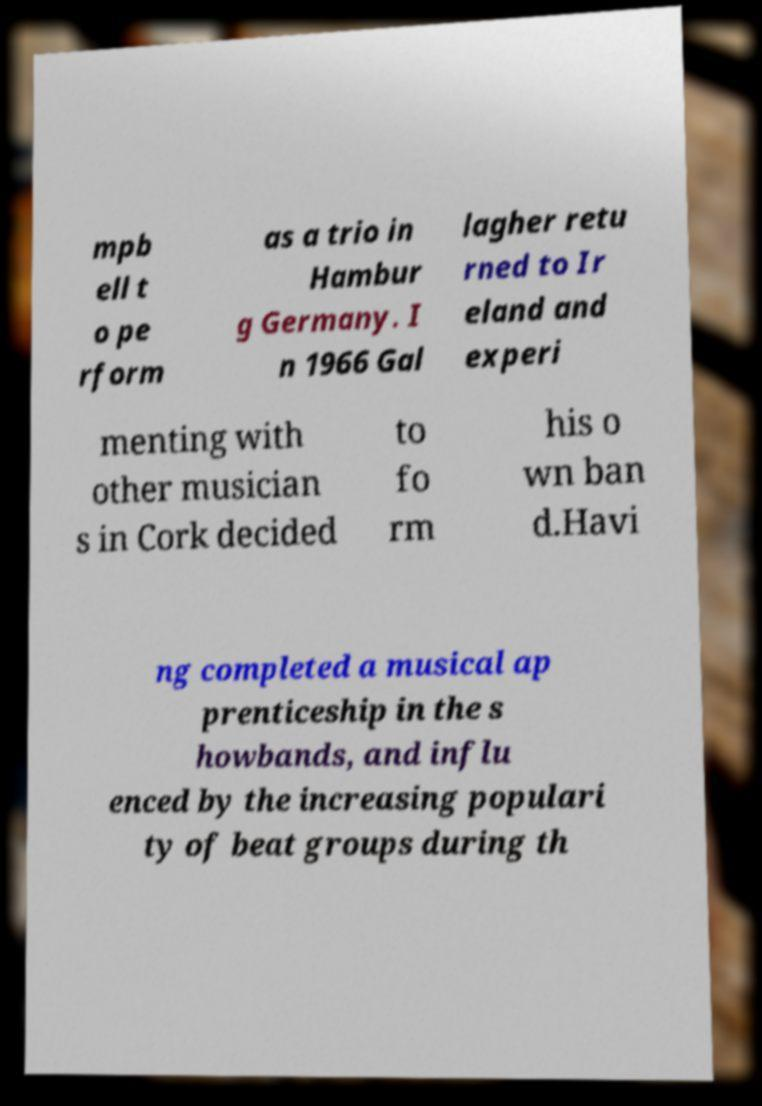Could you assist in decoding the text presented in this image and type it out clearly? mpb ell t o pe rform as a trio in Hambur g Germany. I n 1966 Gal lagher retu rned to Ir eland and experi menting with other musician s in Cork decided to fo rm his o wn ban d.Havi ng completed a musical ap prenticeship in the s howbands, and influ enced by the increasing populari ty of beat groups during th 